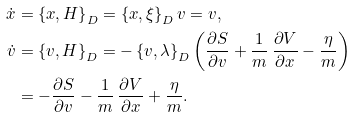Convert formula to latex. <formula><loc_0><loc_0><loc_500><loc_500>\dot { x } & = \left \{ x , H \right \} _ { D } = \left \{ x , \xi \right \} _ { D } v = v , \\ \dot { v } & = \left \{ v , H \right \} _ { D } = - \left \{ v , \lambda \right \} _ { D } \left ( \frac { \partial S } { \partial v } + \frac { 1 } { m } \, \frac { \partial V } { \partial x } - \frac { \eta } { m } \right ) \\ & = - \frac { \partial S } { \partial v } - \frac { 1 } { m } \, \frac { \partial V } { \partial x } + \frac { \eta } { m } .</formula> 